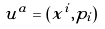<formula> <loc_0><loc_0><loc_500><loc_500>u ^ { a } = ( x ^ { i } , p _ { i } )</formula> 